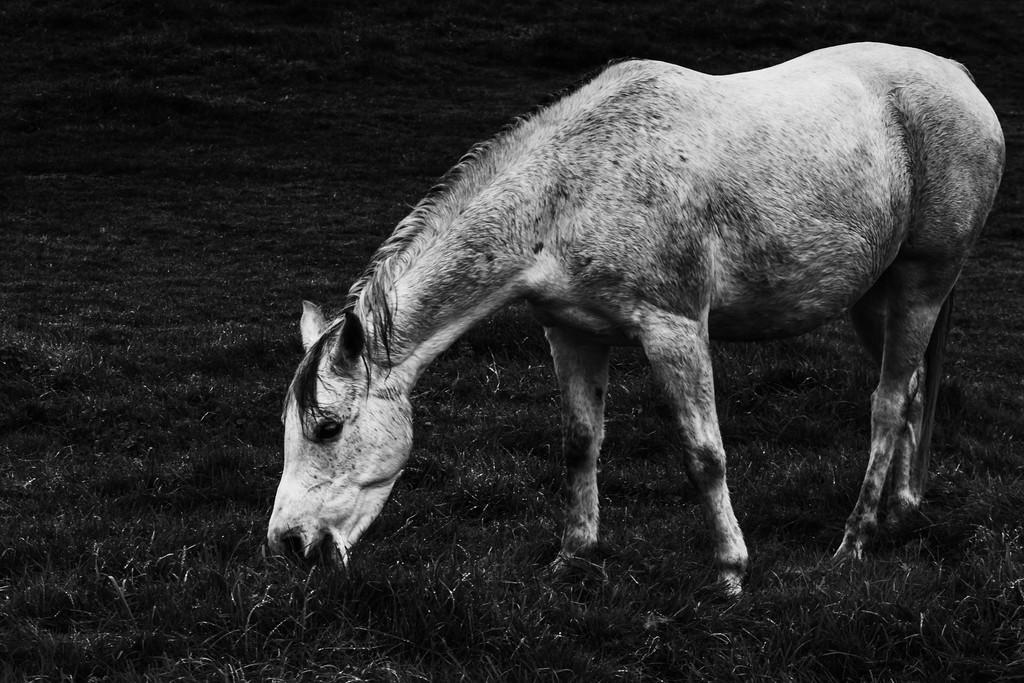What animal is present in the image? There is a horse in the image. What is the horse doing in the image? The horse is eating grass. What type of rose is the horse holding in its mouth in the image? There is no rose present in the image; the horse is eating grass. What kind of jewel is the horse wearing around its neck in the image? There is no jewel present in the image; the horse is simply eating grass. 